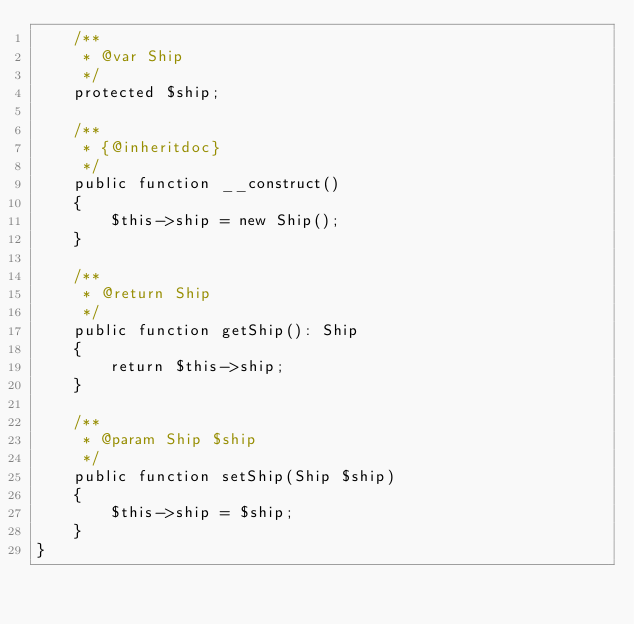<code> <loc_0><loc_0><loc_500><loc_500><_PHP_>    /**
     * @var Ship
     */
    protected $ship;

    /**
     * {@inheritdoc}
     */
    public function __construct()
    {
        $this->ship = new Ship();
    }

    /**
     * @return Ship
     */
    public function getShip(): Ship
    {
        return $this->ship;
    }

    /**
     * @param Ship $ship
     */
    public function setShip(Ship $ship)
    {
        $this->ship = $ship;
    }
}
</code> 